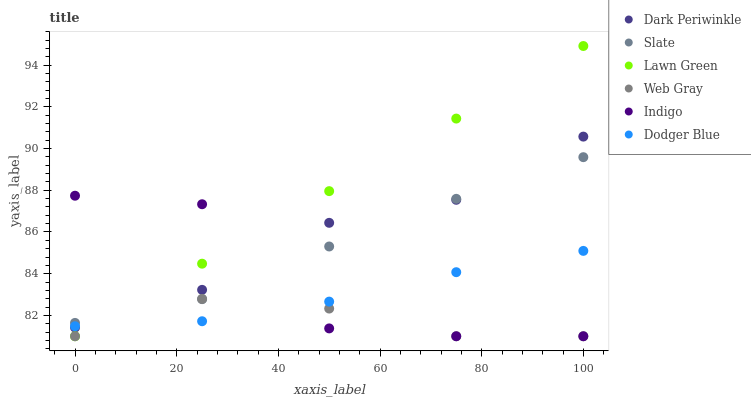Does Web Gray have the minimum area under the curve?
Answer yes or no. Yes. Does Lawn Green have the maximum area under the curve?
Answer yes or no. Yes. Does Indigo have the minimum area under the curve?
Answer yes or no. No. Does Indigo have the maximum area under the curve?
Answer yes or no. No. Is Lawn Green the smoothest?
Answer yes or no. Yes. Is Indigo the roughest?
Answer yes or no. Yes. Is Web Gray the smoothest?
Answer yes or no. No. Is Web Gray the roughest?
Answer yes or no. No. Does Lawn Green have the lowest value?
Answer yes or no. Yes. Does Slate have the lowest value?
Answer yes or no. No. Does Lawn Green have the highest value?
Answer yes or no. Yes. Does Indigo have the highest value?
Answer yes or no. No. Is Web Gray less than Dark Periwinkle?
Answer yes or no. Yes. Is Slate greater than Dodger Blue?
Answer yes or no. Yes. Does Slate intersect Dark Periwinkle?
Answer yes or no. Yes. Is Slate less than Dark Periwinkle?
Answer yes or no. No. Is Slate greater than Dark Periwinkle?
Answer yes or no. No. Does Web Gray intersect Dark Periwinkle?
Answer yes or no. No. 